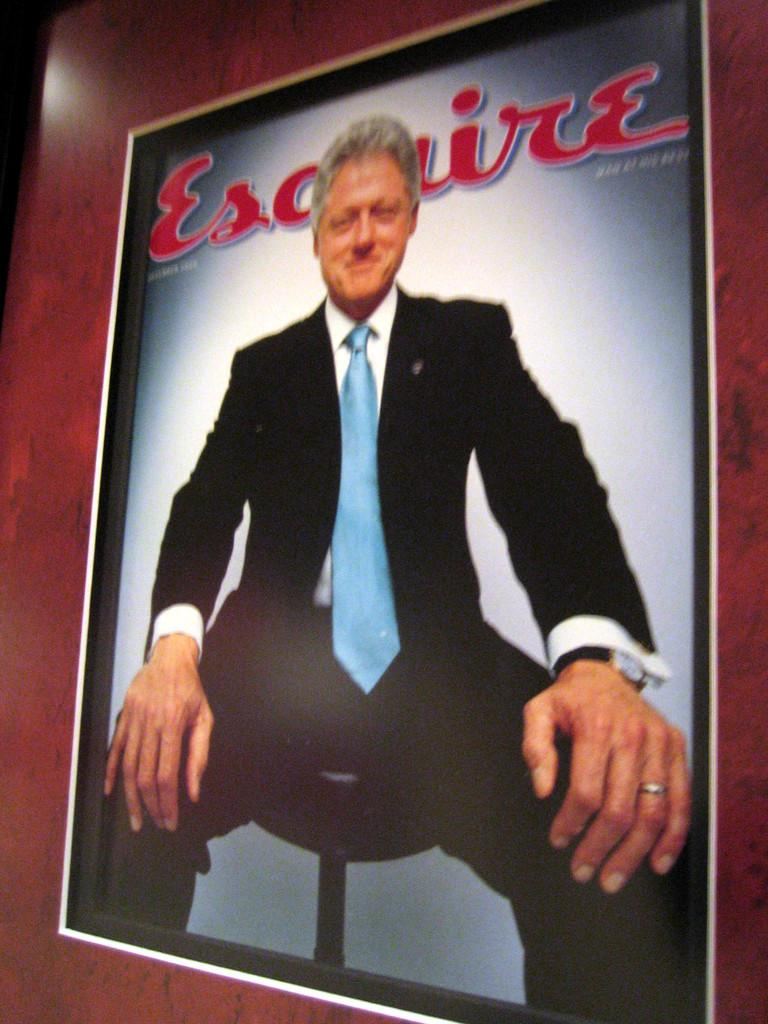What object is present in the image that typically holds a picture? There is a photo frame in the image. What can be seen inside the photo frame? The photo frame contains a picture of a man. Is there any text present in the photo frame? Yes, there is text in the photo frame. What type of watch is the man wearing in the photo frame? There is no watch visible in the photo frame, as it only contains a picture of a man and text. 